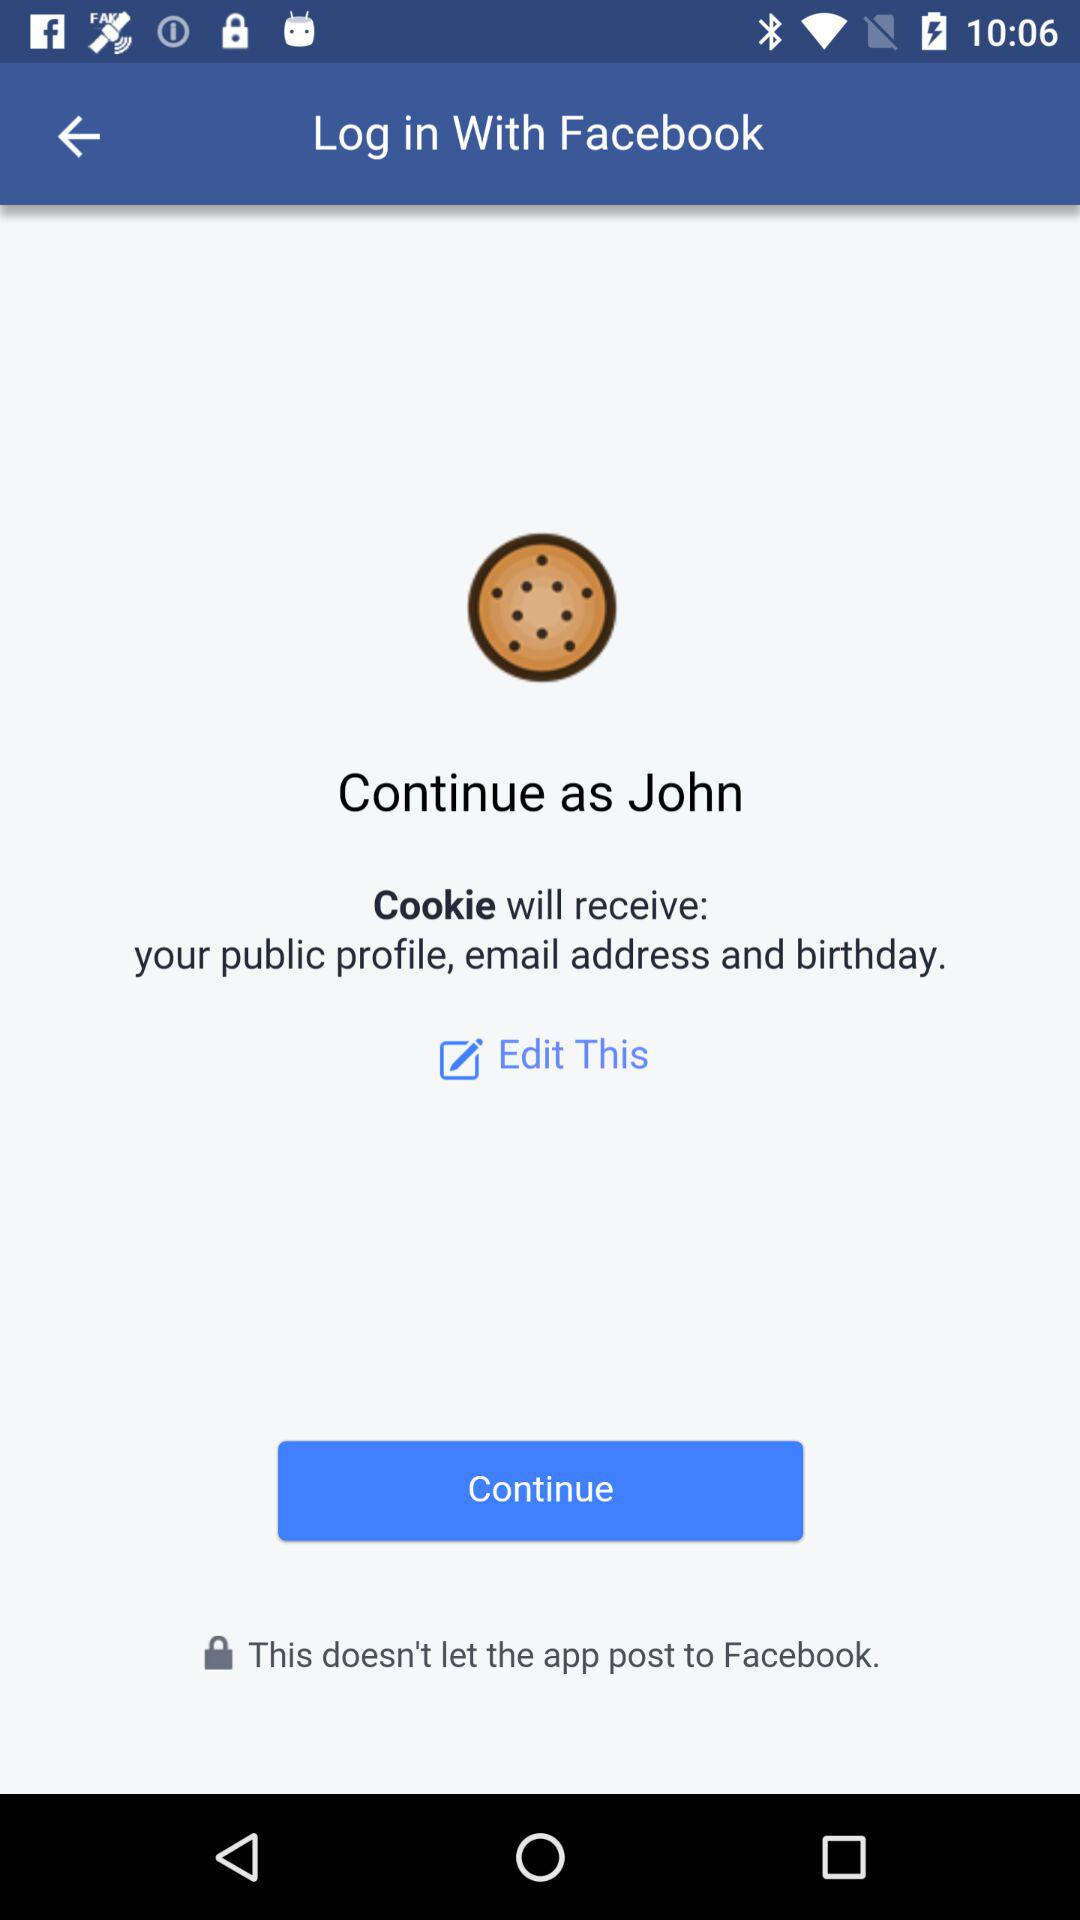What application is asking for permission? The application "Cookie" is asking for permission. 